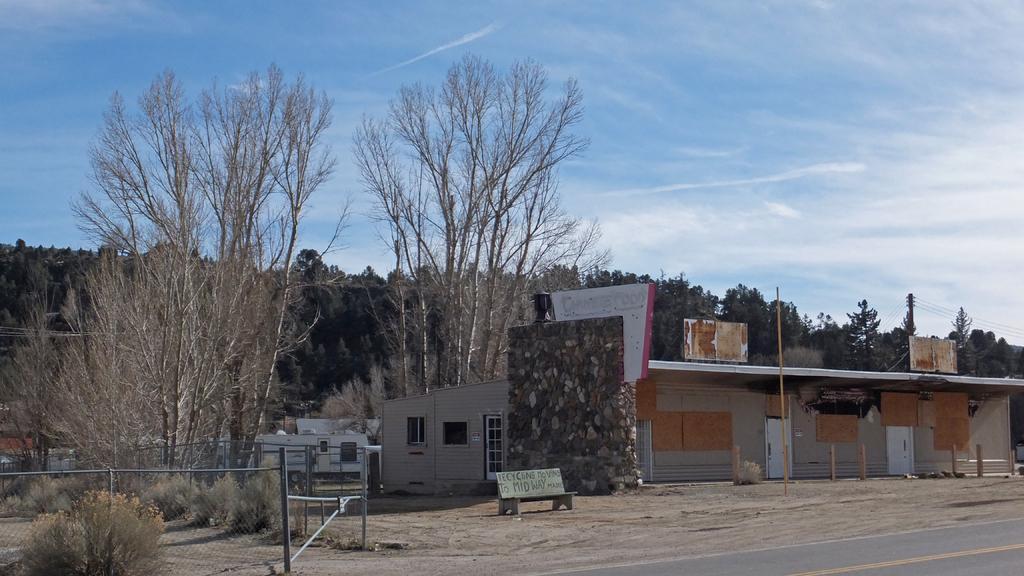Please provide a concise description of this image. In the picture we can see some part of the road and a sand surface and on it we can see some plants, trees, bench, and house with windows and door and some pole near it and in the background we can see trees and sky with clouds. 